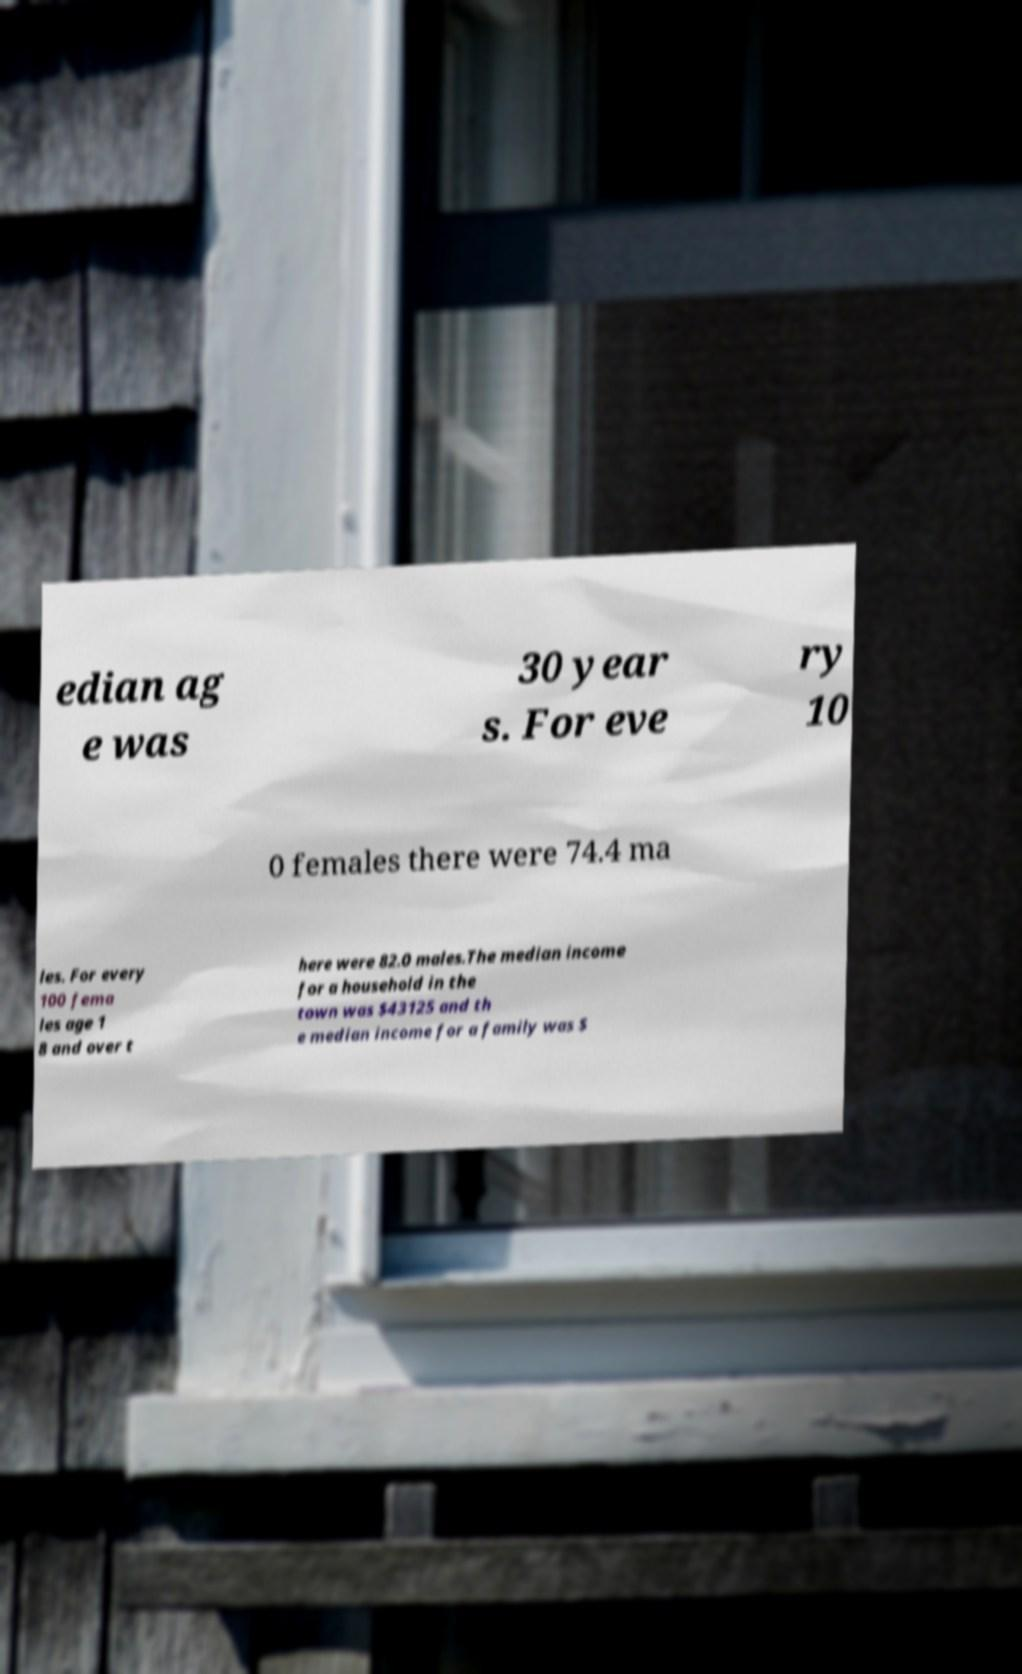What messages or text are displayed in this image? I need them in a readable, typed format. edian ag e was 30 year s. For eve ry 10 0 females there were 74.4 ma les. For every 100 fema les age 1 8 and over t here were 82.0 males.The median income for a household in the town was $43125 and th e median income for a family was $ 